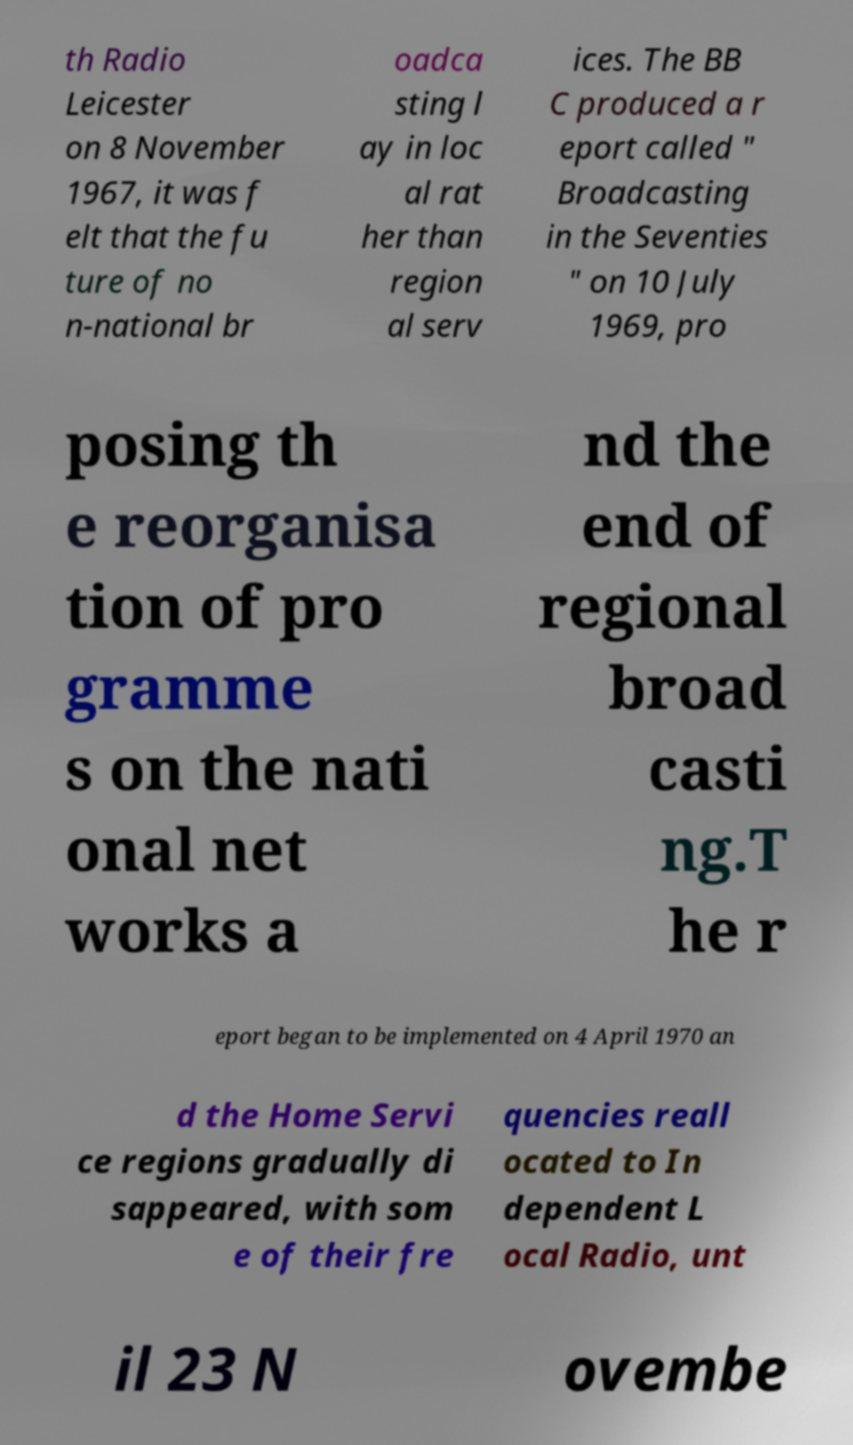I need the written content from this picture converted into text. Can you do that? th Radio Leicester on 8 November 1967, it was f elt that the fu ture of no n-national br oadca sting l ay in loc al rat her than region al serv ices. The BB C produced a r eport called " Broadcasting in the Seventies " on 10 July 1969, pro posing th e reorganisa tion of pro gramme s on the nati onal net works a nd the end of regional broad casti ng.T he r eport began to be implemented on 4 April 1970 an d the Home Servi ce regions gradually di sappeared, with som e of their fre quencies reall ocated to In dependent L ocal Radio, unt il 23 N ovembe 